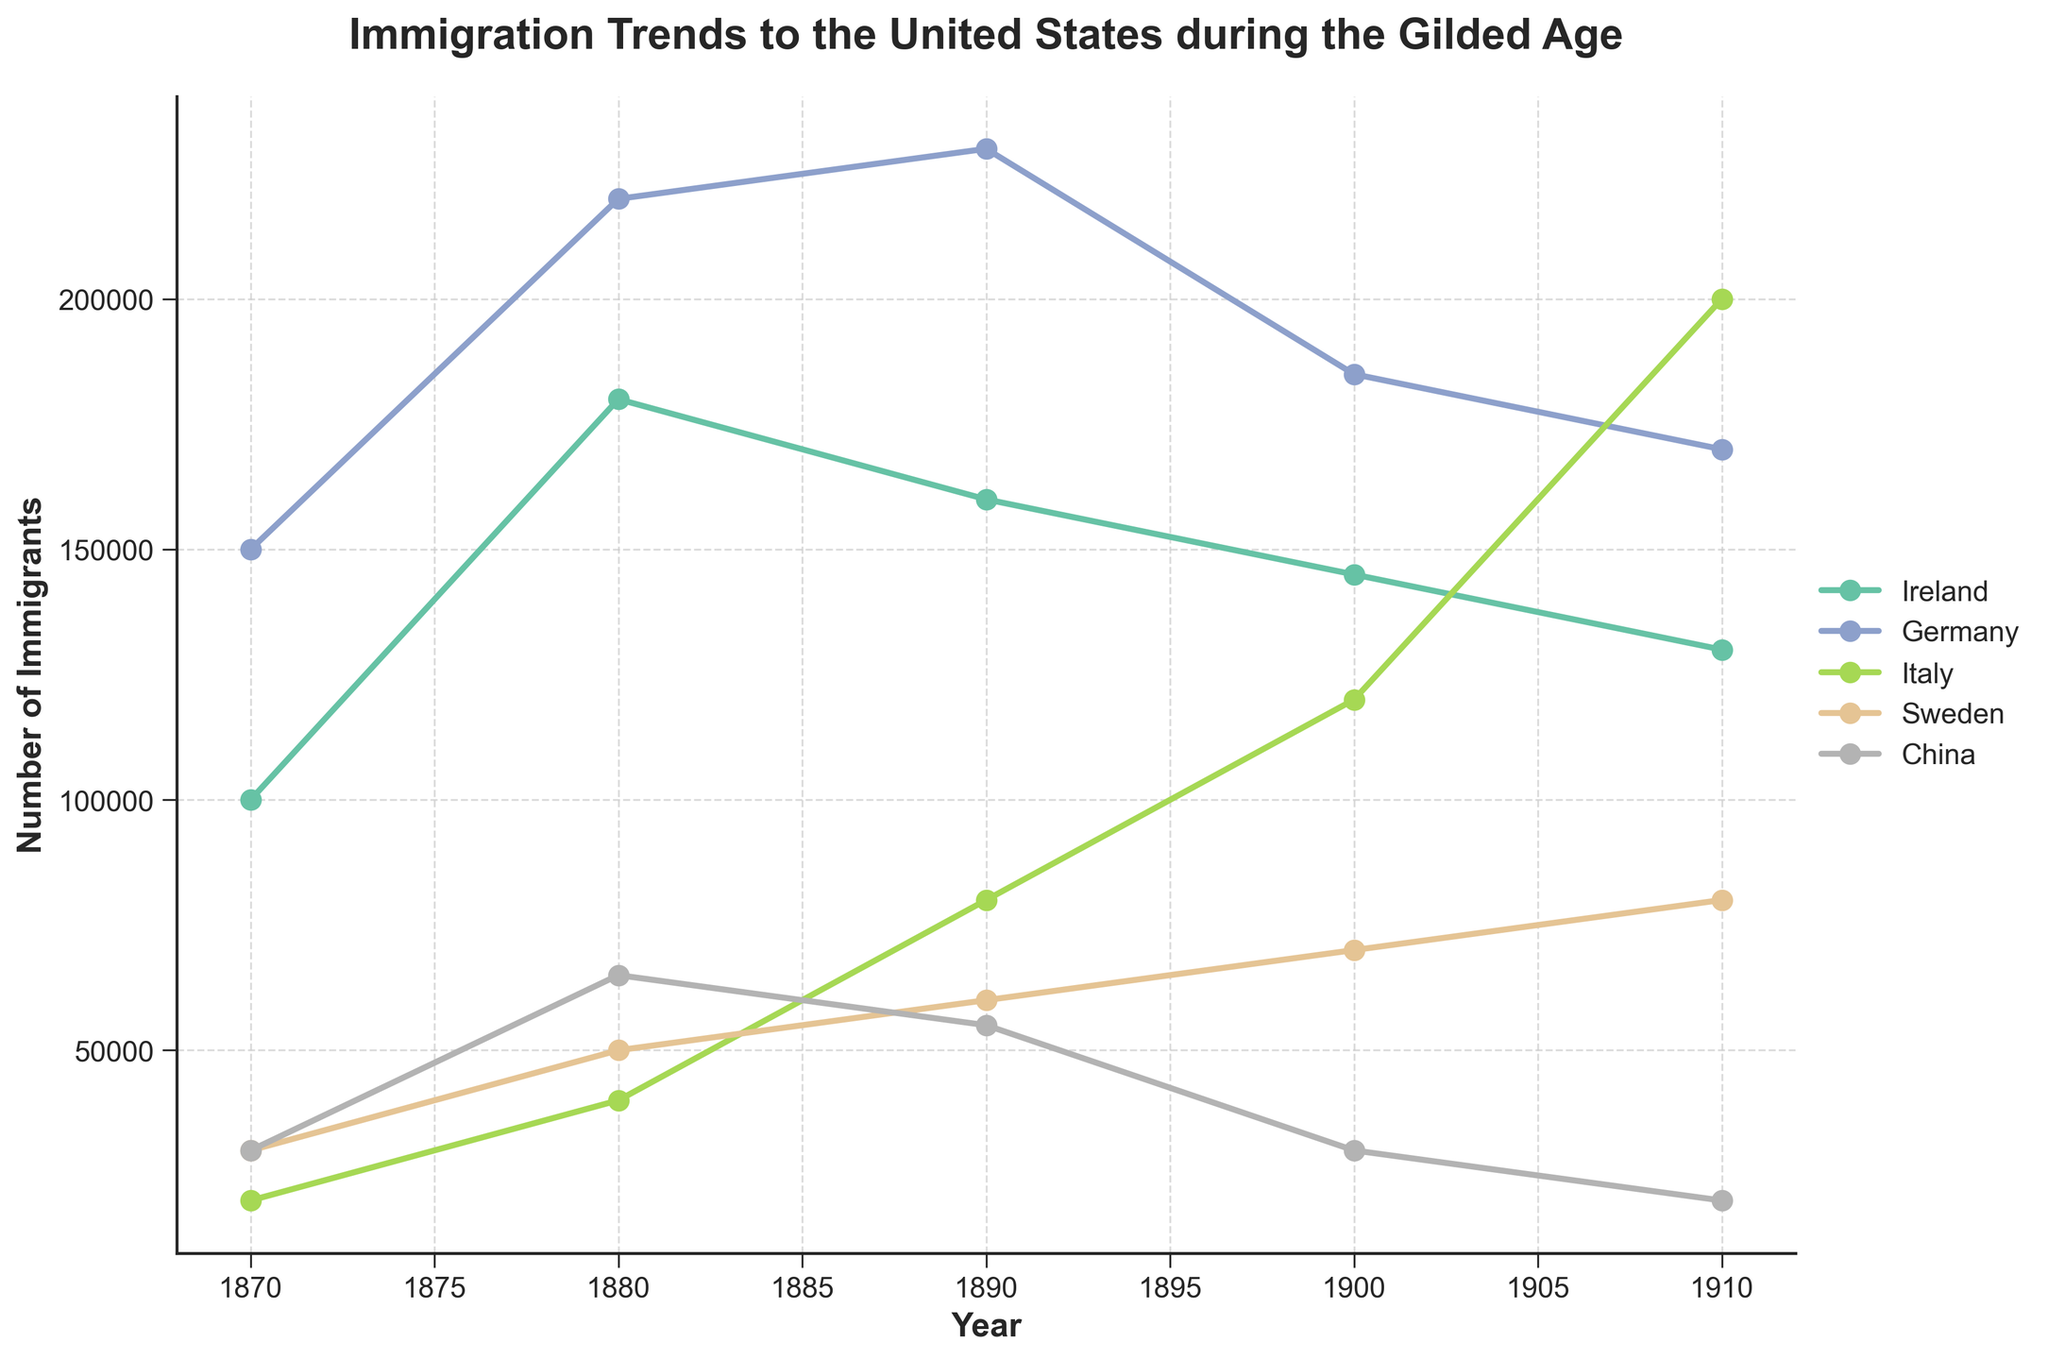What is the title of the plot? The title is typically located at the top of the plot and provides an overview of what the plot is about.
Answer: Immigration Trends to the United States during the Gilded Age How many countries are represented in the plot? The legend on the right side of the plot lists all the countries included in the data. Count the unique country names in the legend.
Answer: 5 Which country had the highest number of immigrants in 1910? Check the y-axis values for the data point corresponding to the year 1910 for each country, and find the one with the highest value.
Answer: Italy How does the number of Chinese immigrants in 1900 compare to that in 1910? Locate the data points for China corresponding to the years 1900 and 1910, then compare their y-axis values.
Answer: The number decreased Which country's immigration numbers remained constant between 1870 and 1910? Examine the trend lines for each country from 1870 to 1910 to see if any of them show no change (flat line).
Answer: None What is the average number of German immigrants from 1870 to 1910? Add the data points for Germany from 1870 to 1910 and divide by the number of data points (i.e., the number of years considered).
Answer: (150000 + 220000 + 230000 + 185000 + 170000) / 5 = 191000 Which country experienced the largest increase in immigration from 1880 to 1890? Calculate the difference in the number of immigrants for each country between 1880 and 1890, then identify the largest increase.
Answer: Italy Was there a trend of decreasing immigration for any country from 1870 to 1910? Analyze the trend lines for each country from 1870 to 1910 to see if any of them show a downward trend throughout the years.
Answer: China By how much did the number of Irish immigrants change from 1880 to 1900? Subtract the number of Irish immigrants in 1900 from the number in 1880.
Answer: 145000 - 180000 = -35000 Which two countries had the closest number of immigrants in 1900? Compare the immigration numbers for each country in 1900 and identify the two closest in value.
Answer: Ireland and Germany 